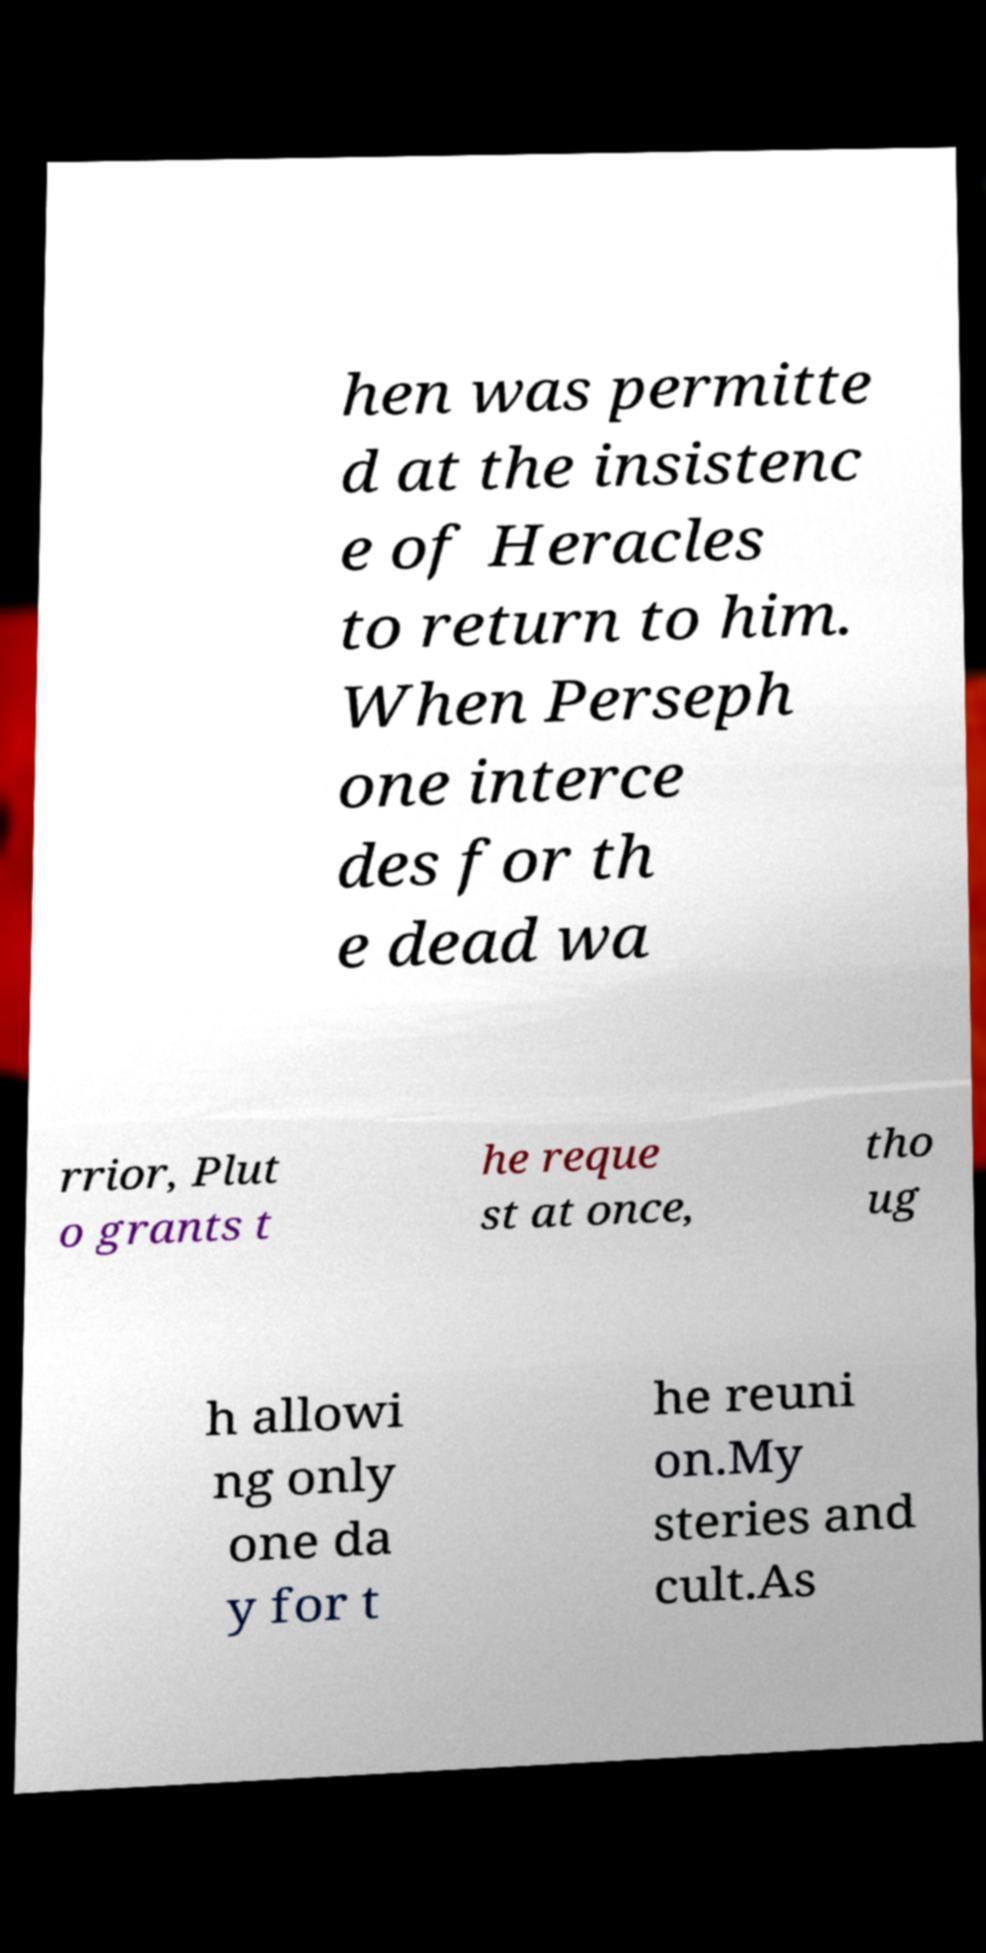Could you extract and type out the text from this image? hen was permitte d at the insistenc e of Heracles to return to him. When Perseph one interce des for th e dead wa rrior, Plut o grants t he reque st at once, tho ug h allowi ng only one da y for t he reuni on.My steries and cult.As 